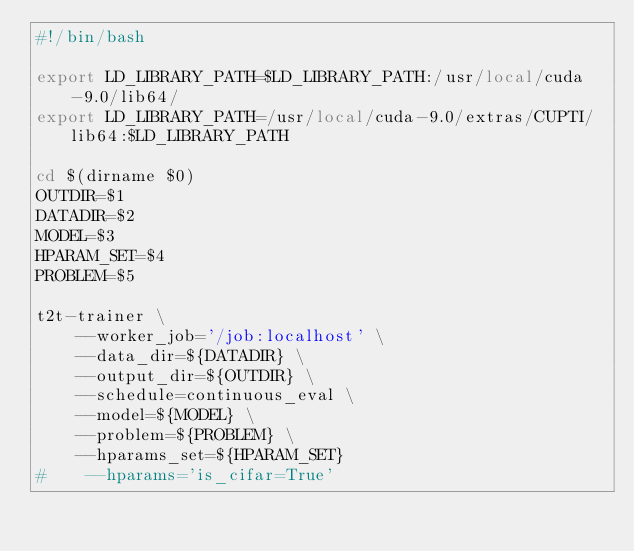Convert code to text. <code><loc_0><loc_0><loc_500><loc_500><_Bash_>#!/bin/bash

export LD_LIBRARY_PATH=$LD_LIBRARY_PATH:/usr/local/cuda-9.0/lib64/
export LD_LIBRARY_PATH=/usr/local/cuda-9.0/extras/CUPTI/lib64:$LD_LIBRARY_PATH

cd $(dirname $0)
OUTDIR=$1
DATADIR=$2
MODEL=$3
HPARAM_SET=$4
PROBLEM=$5

t2t-trainer \
    --worker_job='/job:localhost' \
    --data_dir=${DATADIR} \
    --output_dir=${OUTDIR} \
    --schedule=continuous_eval \
    --model=${MODEL} \
    --problem=${PROBLEM} \
    --hparams_set=${HPARAM_SET}
#    --hparams='is_cifar=True'</code> 